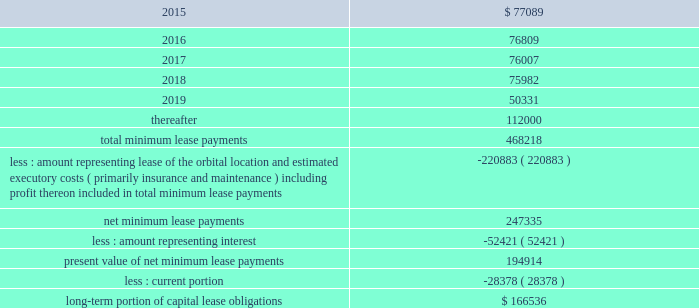Dish network corporation notes to consolidated financial statements - continued capital lease obligations anik f3 .
Anik f3 , an fss satellite , was launched and commenced commercial operation during april 2007 .
This satellite is accounted for as a capital lease and depreciated over the term of the satellite service agreement .
We have leased 100% ( 100 % ) of the ku-band capacity on anik f3 for a period of 15 years .
Ciel ii .
Ciel ii , a canadian dbs satellite , was launched in december 2008 and commenced commercial operation during february 2009 .
This satellite is accounted for as a capital lease and depreciated over the term of the satellite service agreement .
We have leased 100% ( 100 % ) of the capacity on ciel ii for an initial 10 year term .
As of december 31 , 2014 and 2013 , we had $ 500 million capitalized for the estimated fair value of satellites acquired under capital leases included in 201cproperty and equipment , net , 201d with related accumulated depreciation of $ 279 million and $ 236 million , respectively .
In our consolidated statements of operations and comprehensive income ( loss ) , we recognized $ 43 million , $ 43 million and $ 43 million in depreciation expense on satellites acquired under capital lease agreements during the years ended december 31 , 2014 , 2013 and 2012 , respectively .
Future minimum lease payments under the capital lease obligations , together with the present value of the net minimum lease payments as of december 31 , 2014 are as follows ( in thousands ) : for the years ended december 31 .
The summary of future maturities of our outstanding long-term debt as of december 31 , 2014 is included in the commitments table in note 16 .
12 .
Income taxes and accounting for uncertainty in income taxes income taxes our income tax policy is to record the estimated future tax effects of temporary differences between the tax bases of assets and liabilities and amounts reported on our consolidated balance sheets , as well as probable operating loss , tax credit and other carryforwards .
Deferred tax assets are offset by valuation allowances when we believe it is more likely than not that net deferred tax assets will not be realized .
We periodically evaluate our need for a valuation allowance .
Determining necessary valuation allowances requires us to make assessments about historical financial information as well as the timing of future events , including the probability of expected future taxable income and available tax planning opportunities .
We file consolidated tax returns in the u.s .
The income taxes of domestic and foreign subsidiaries not included in the u.s .
Tax group are presented in our consolidated financial statements based on a separate return basis for each tax paying entity. .
What percentage of future minimum lease payments under the capital lease obligations is due in 2019? 
Computations: (50331 / 468218)
Answer: 0.10749. 